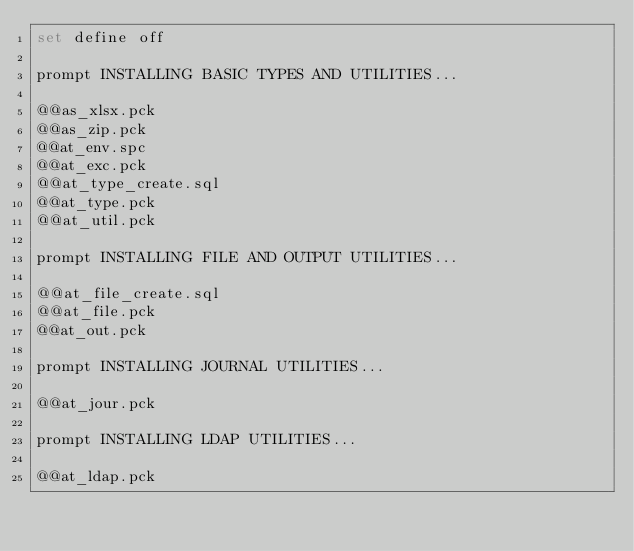Convert code to text. <code><loc_0><loc_0><loc_500><loc_500><_SQL_>set define off

prompt INSTALLING BASIC TYPES AND UTILITIES...

@@as_xlsx.pck
@@as_zip.pck
@@at_env.spc
@@at_exc.pck
@@at_type_create.sql
@@at_type.pck
@@at_util.pck

prompt INSTALLING FILE AND OUTPUT UTILITIES...

@@at_file_create.sql
@@at_file.pck
@@at_out.pck

prompt INSTALLING JOURNAL UTILITIES...

@@at_jour.pck

prompt INSTALLING LDAP UTILITIES...

@@at_ldap.pck
</code> 